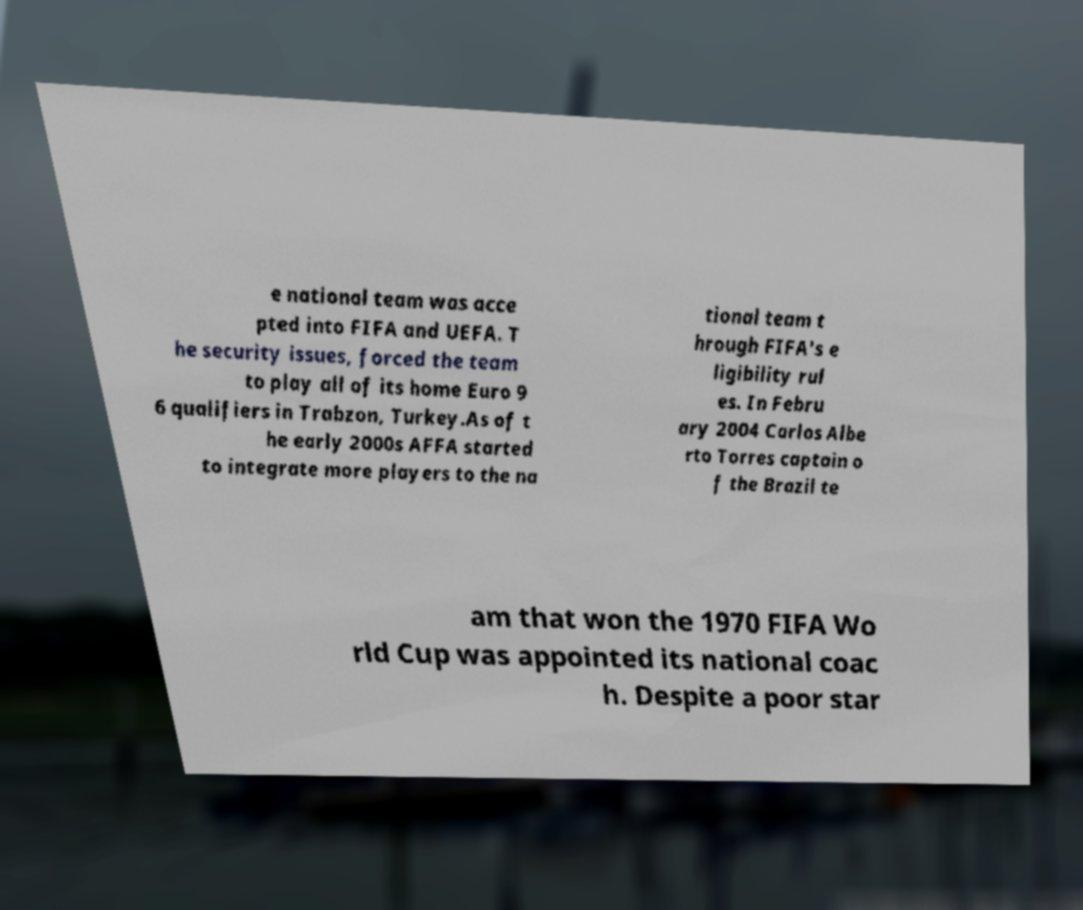Can you accurately transcribe the text from the provided image for me? e national team was acce pted into FIFA and UEFA. T he security issues, forced the team to play all of its home Euro 9 6 qualifiers in Trabzon, Turkey.As of t he early 2000s AFFA started to integrate more players to the na tional team t hrough FIFA's e ligibility rul es. In Febru ary 2004 Carlos Albe rto Torres captain o f the Brazil te am that won the 1970 FIFA Wo rld Cup was appointed its national coac h. Despite a poor star 